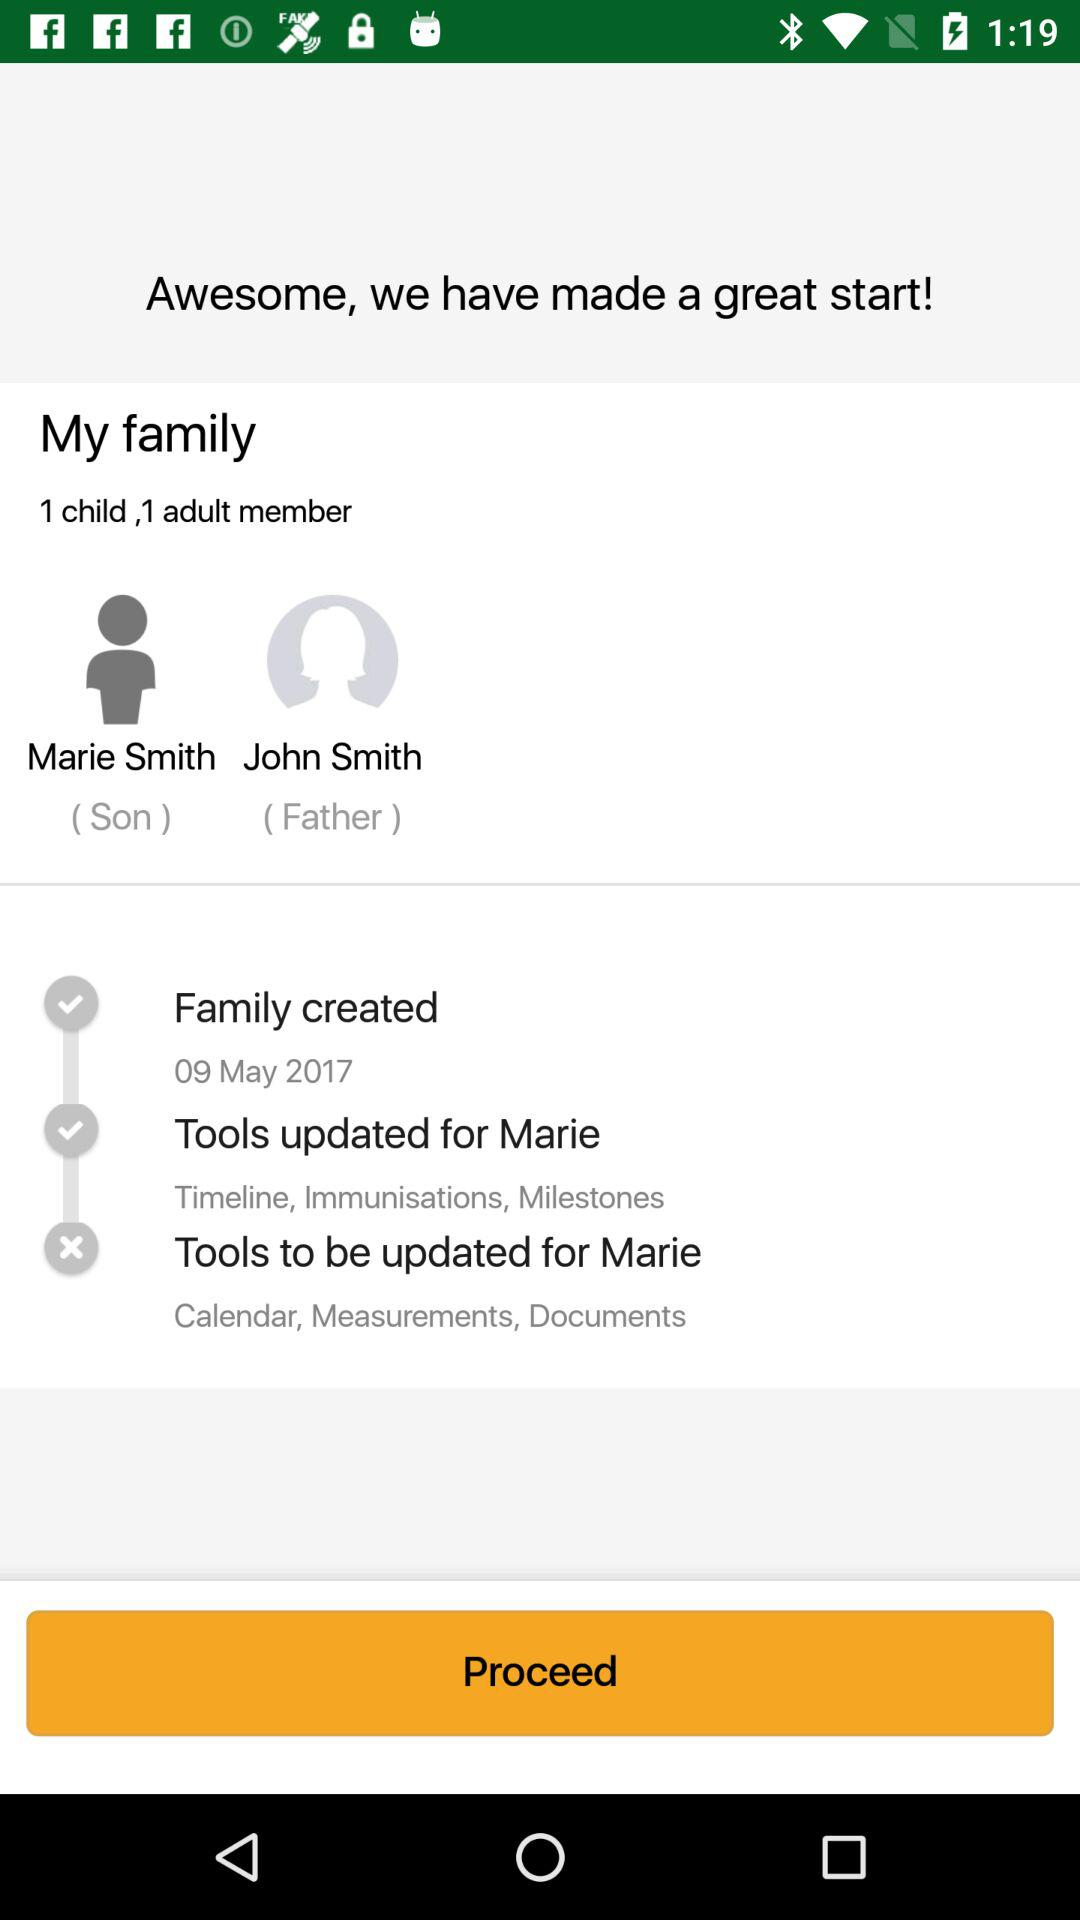What tools will be updated for Marie? The tools are "Calendar", "Measurements" and "Documents". 